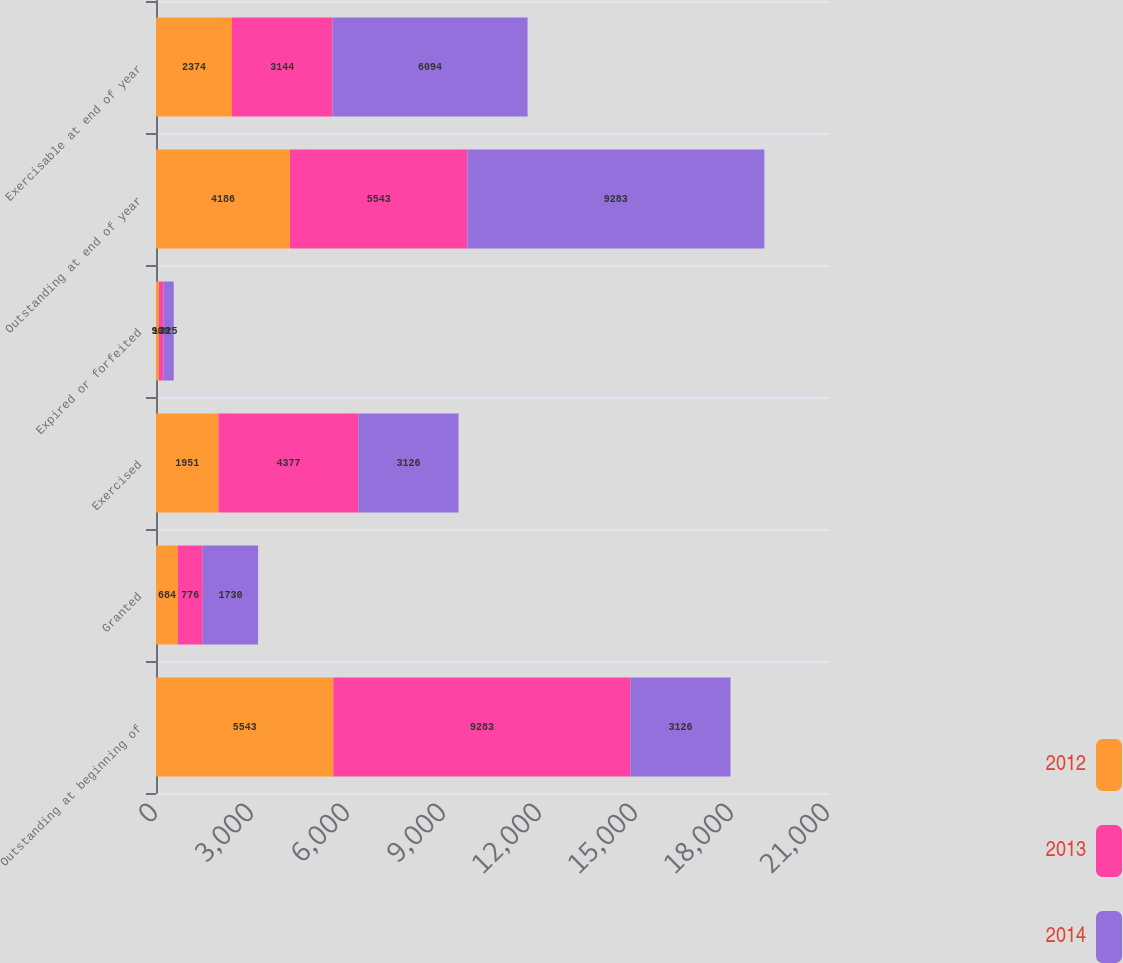<chart> <loc_0><loc_0><loc_500><loc_500><stacked_bar_chart><ecel><fcel>Outstanding at beginning of<fcel>Granted<fcel>Exercised<fcel>Expired or forfeited<fcel>Outstanding at end of year<fcel>Exercisable at end of year<nl><fcel>2012<fcel>5543<fcel>684<fcel>1951<fcel>90<fcel>4186<fcel>2374<nl><fcel>2013<fcel>9283<fcel>776<fcel>4377<fcel>139<fcel>5543<fcel>3144<nl><fcel>2014<fcel>3126<fcel>1730<fcel>3126<fcel>325<fcel>9283<fcel>6094<nl></chart> 